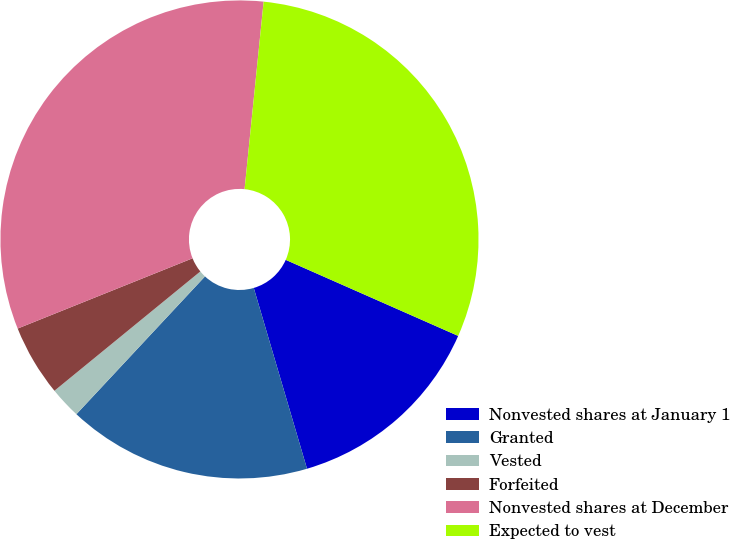<chart> <loc_0><loc_0><loc_500><loc_500><pie_chart><fcel>Nonvested shares at January 1<fcel>Granted<fcel>Vested<fcel>Forfeited<fcel>Nonvested shares at December<fcel>Expected to vest<nl><fcel>13.83%<fcel>16.51%<fcel>2.14%<fcel>4.83%<fcel>32.69%<fcel>30.0%<nl></chart> 